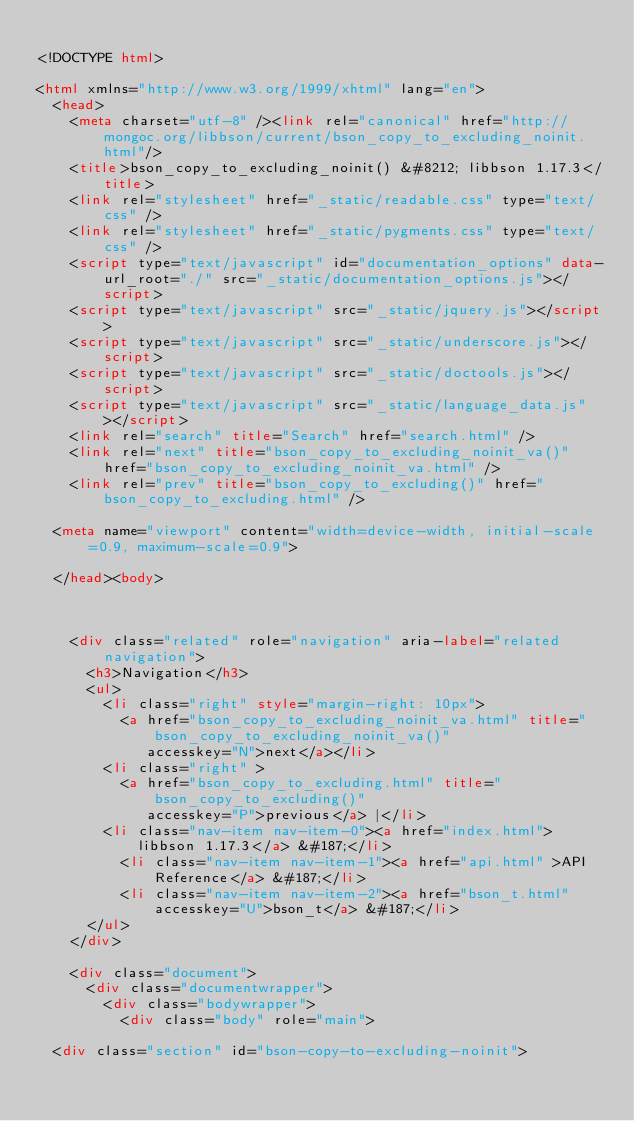<code> <loc_0><loc_0><loc_500><loc_500><_HTML_>
<!DOCTYPE html>

<html xmlns="http://www.w3.org/1999/xhtml" lang="en">
  <head>
    <meta charset="utf-8" /><link rel="canonical" href="http://mongoc.org/libbson/current/bson_copy_to_excluding_noinit.html"/>
    <title>bson_copy_to_excluding_noinit() &#8212; libbson 1.17.3</title>
    <link rel="stylesheet" href="_static/readable.css" type="text/css" />
    <link rel="stylesheet" href="_static/pygments.css" type="text/css" />
    <script type="text/javascript" id="documentation_options" data-url_root="./" src="_static/documentation_options.js"></script>
    <script type="text/javascript" src="_static/jquery.js"></script>
    <script type="text/javascript" src="_static/underscore.js"></script>
    <script type="text/javascript" src="_static/doctools.js"></script>
    <script type="text/javascript" src="_static/language_data.js"></script>
    <link rel="search" title="Search" href="search.html" />
    <link rel="next" title="bson_copy_to_excluding_noinit_va()" href="bson_copy_to_excluding_noinit_va.html" />
    <link rel="prev" title="bson_copy_to_excluding()" href="bson_copy_to_excluding.html" />
   
  <meta name="viewport" content="width=device-width, initial-scale=0.9, maximum-scale=0.9">

  </head><body>
  
  

    <div class="related" role="navigation" aria-label="related navigation">
      <h3>Navigation</h3>
      <ul>
        <li class="right" style="margin-right: 10px">
          <a href="bson_copy_to_excluding_noinit_va.html" title="bson_copy_to_excluding_noinit_va()"
             accesskey="N">next</a></li>
        <li class="right" >
          <a href="bson_copy_to_excluding.html" title="bson_copy_to_excluding()"
             accesskey="P">previous</a> |</li>
        <li class="nav-item nav-item-0"><a href="index.html">libbson 1.17.3</a> &#187;</li>
          <li class="nav-item nav-item-1"><a href="api.html" >API Reference</a> &#187;</li>
          <li class="nav-item nav-item-2"><a href="bson_t.html" accesskey="U">bson_t</a> &#187;</li> 
      </ul>
    </div>  

    <div class="document">
      <div class="documentwrapper">
        <div class="bodywrapper">
          <div class="body" role="main">
            
  <div class="section" id="bson-copy-to-excluding-noinit"></code> 